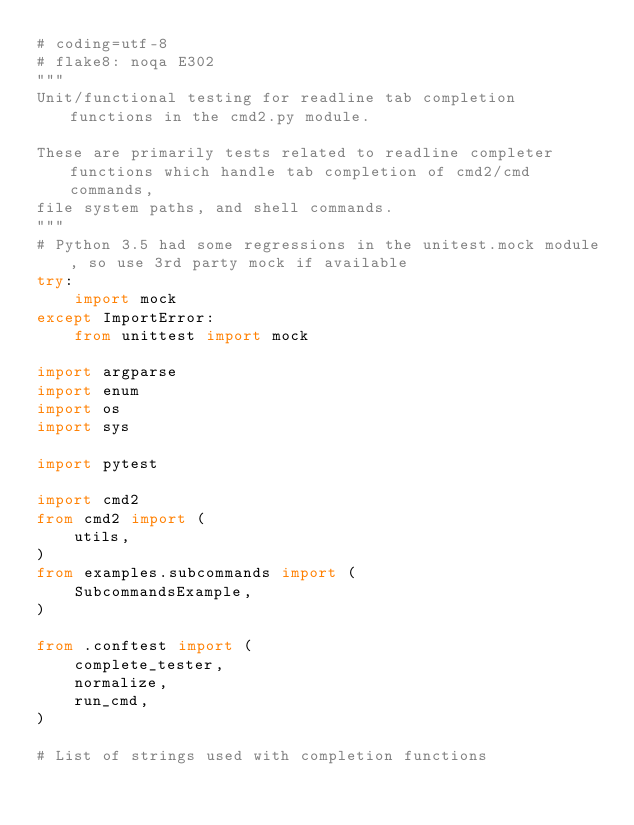Convert code to text. <code><loc_0><loc_0><loc_500><loc_500><_Python_># coding=utf-8
# flake8: noqa E302
"""
Unit/functional testing for readline tab completion functions in the cmd2.py module.

These are primarily tests related to readline completer functions which handle tab completion of cmd2/cmd commands,
file system paths, and shell commands.
"""
# Python 3.5 had some regressions in the unitest.mock module, so use 3rd party mock if available
try:
    import mock
except ImportError:
    from unittest import mock

import argparse
import enum
import os
import sys

import pytest

import cmd2
from cmd2 import (
    utils,
)
from examples.subcommands import (
    SubcommandsExample,
)

from .conftest import (
    complete_tester,
    normalize,
    run_cmd,
)

# List of strings used with completion functions</code> 